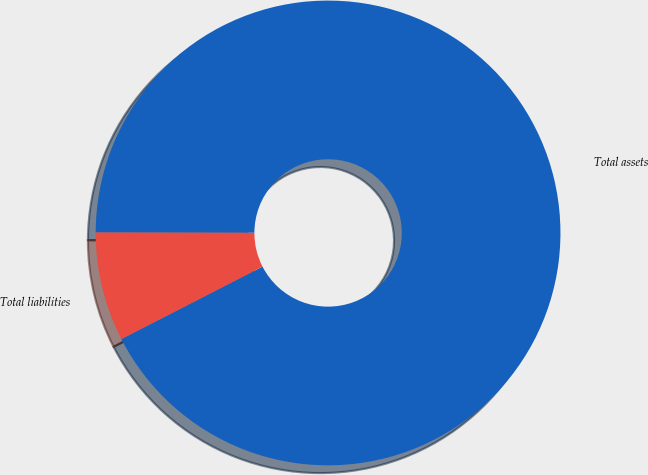Convert chart to OTSL. <chart><loc_0><loc_0><loc_500><loc_500><pie_chart><fcel>Total assets<fcel>Total liabilities<nl><fcel>92.42%<fcel>7.58%<nl></chart> 